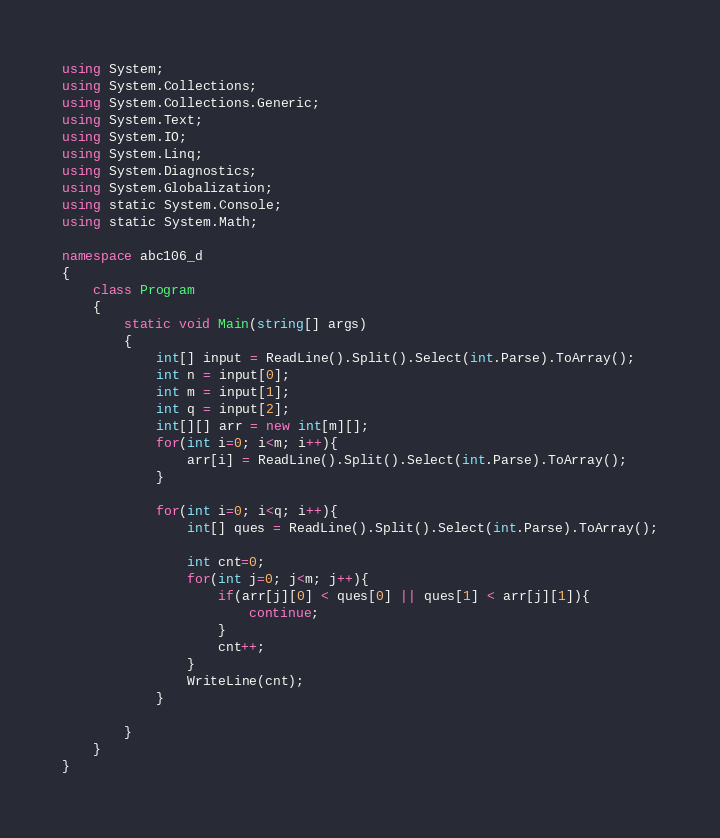<code> <loc_0><loc_0><loc_500><loc_500><_C#_>using System;
using System.Collections;
using System.Collections.Generic;
using System.Text;
using System.IO;
using System.Linq;
using System.Diagnostics;
using System.Globalization;
using static System.Console;
using static System.Math;

namespace abc106_d
{
    class Program
    {
        static void Main(string[] args)
        {
            int[] input = ReadLine().Split().Select(int.Parse).ToArray();
            int n = input[0];
            int m = input[1];
            int q = input[2];
            int[][] arr = new int[m][];
            for(int i=0; i<m; i++){
                arr[i] = ReadLine().Split().Select(int.Parse).ToArray();
            }

            for(int i=0; i<q; i++){
                int[] ques = ReadLine().Split().Select(int.Parse).ToArray();

                int cnt=0;
                for(int j=0; j<m; j++){
                    if(arr[j][0] < ques[0] || ques[1] < arr[j][1]){
                        continue;
                    }
                    cnt++;
                }
                WriteLine(cnt);
            }

        }
    }
}</code> 